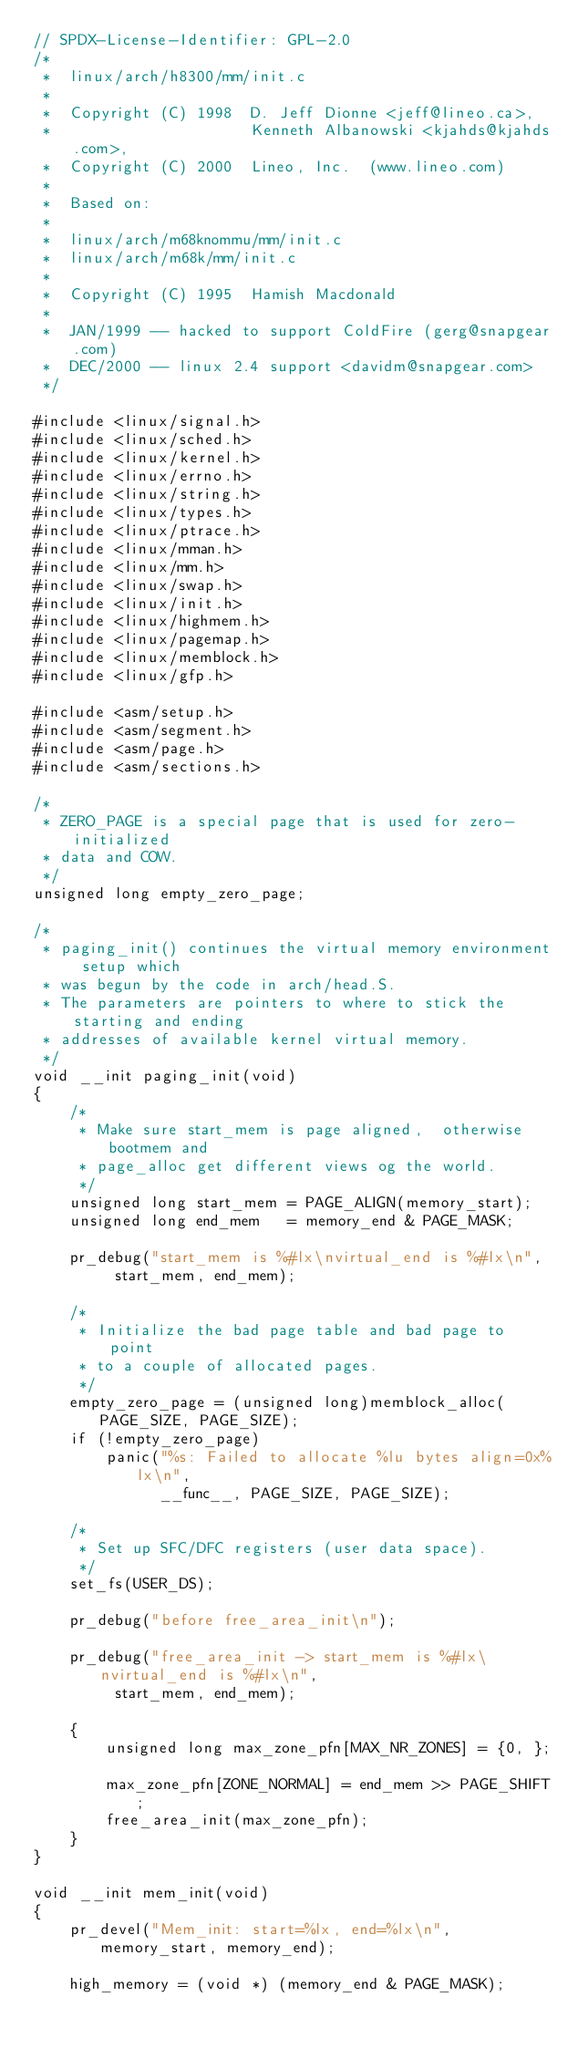Convert code to text. <code><loc_0><loc_0><loc_500><loc_500><_C_>// SPDX-License-Identifier: GPL-2.0
/*
 *  linux/arch/h8300/mm/init.c
 *
 *  Copyright (C) 1998  D. Jeff Dionne <jeff@lineo.ca>,
 *                      Kenneth Albanowski <kjahds@kjahds.com>,
 *  Copyright (C) 2000  Lineo, Inc.  (www.lineo.com)
 *
 *  Based on:
 *
 *  linux/arch/m68knommu/mm/init.c
 *  linux/arch/m68k/mm/init.c
 *
 *  Copyright (C) 1995  Hamish Macdonald
 *
 *  JAN/1999 -- hacked to support ColdFire (gerg@snapgear.com)
 *  DEC/2000 -- linux 2.4 support <davidm@snapgear.com>
 */

#include <linux/signal.h>
#include <linux/sched.h>
#include <linux/kernel.h>
#include <linux/errno.h>
#include <linux/string.h>
#include <linux/types.h>
#include <linux/ptrace.h>
#include <linux/mman.h>
#include <linux/mm.h>
#include <linux/swap.h>
#include <linux/init.h>
#include <linux/highmem.h>
#include <linux/pagemap.h>
#include <linux/memblock.h>
#include <linux/gfp.h>

#include <asm/setup.h>
#include <asm/segment.h>
#include <asm/page.h>
#include <asm/sections.h>

/*
 * ZERO_PAGE is a special page that is used for zero-initialized
 * data and COW.
 */
unsigned long empty_zero_page;

/*
 * paging_init() continues the virtual memory environment setup which
 * was begun by the code in arch/head.S.
 * The parameters are pointers to where to stick the starting and ending
 * addresses of available kernel virtual memory.
 */
void __init paging_init(void)
{
	/*
	 * Make sure start_mem is page aligned,  otherwise bootmem and
	 * page_alloc get different views og the world.
	 */
	unsigned long start_mem = PAGE_ALIGN(memory_start);
	unsigned long end_mem   = memory_end & PAGE_MASK;

	pr_debug("start_mem is %#lx\nvirtual_end is %#lx\n",
		 start_mem, end_mem);

	/*
	 * Initialize the bad page table and bad page to point
	 * to a couple of allocated pages.
	 */
	empty_zero_page = (unsigned long)memblock_alloc(PAGE_SIZE, PAGE_SIZE);
	if (!empty_zero_page)
		panic("%s: Failed to allocate %lu bytes align=0x%lx\n",
		      __func__, PAGE_SIZE, PAGE_SIZE);

	/*
	 * Set up SFC/DFC registers (user data space).
	 */
	set_fs(USER_DS);

	pr_debug("before free_area_init\n");

	pr_debug("free_area_init -> start_mem is %#lx\nvirtual_end is %#lx\n",
		 start_mem, end_mem);

	{
		unsigned long max_zone_pfn[MAX_NR_ZONES] = {0, };

		max_zone_pfn[ZONE_NORMAL] = end_mem >> PAGE_SHIFT;
		free_area_init(max_zone_pfn);
	}
}

void __init mem_init(void)
{
	pr_devel("Mem_init: start=%lx, end=%lx\n", memory_start, memory_end);

	high_memory = (void *) (memory_end & PAGE_MASK);</code> 